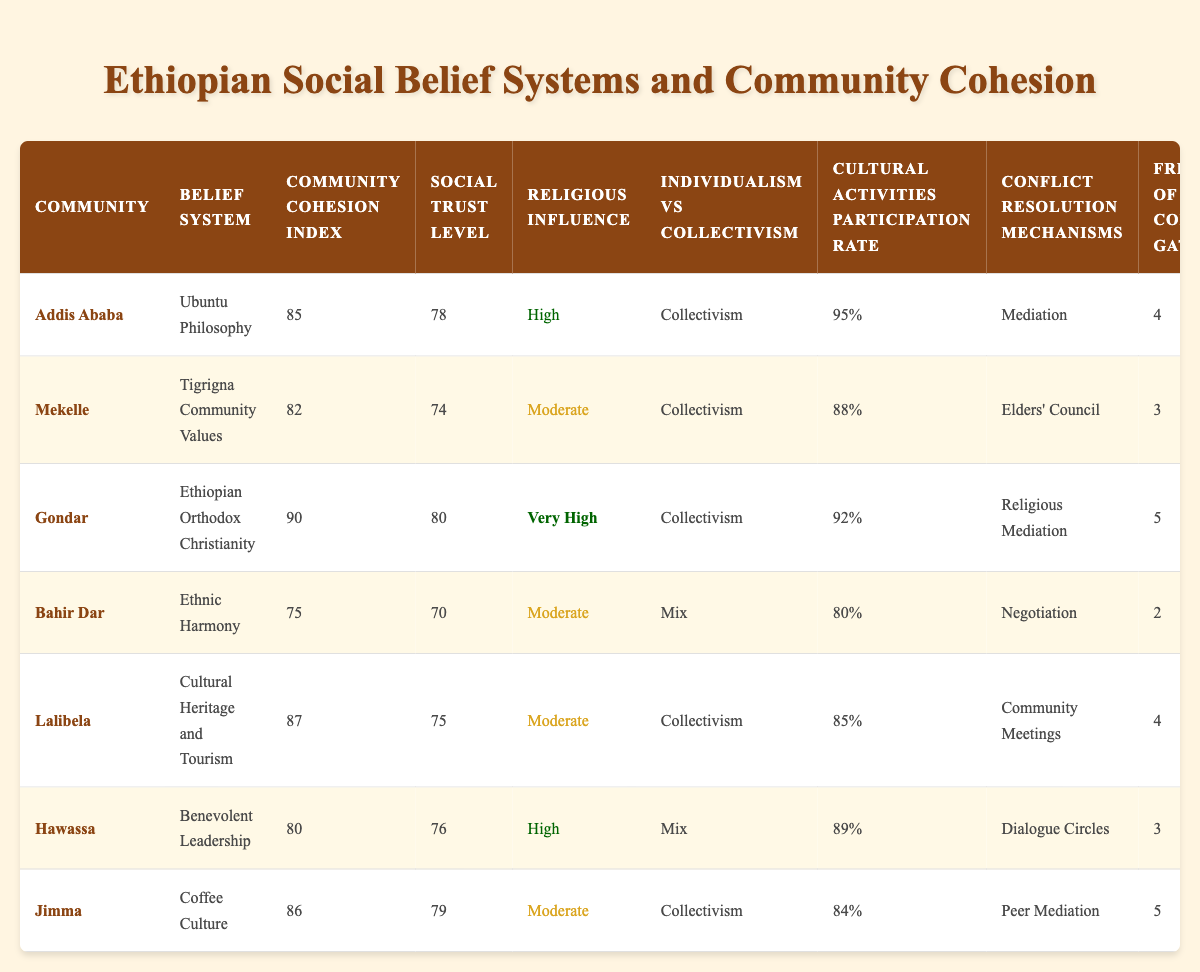What is the Community Cohesion Index for Gondar? The Community Cohesion Index is listed directly in the table under the corresponding row for Gondar, which shows a value of 90.
Answer: 90 What is the Social Trust Level for the community with the highest Community Cohesion Index? By looking at the Community Cohesion Index, Gondar has the highest value of 90. The corresponding Social Trust Level for Gondar is 80.
Answer: 80 Which community has the highest Cultural Activities Participation Rate? The Cultural Activities Participation Rate is compared across all communities, with Addis Ababa showing the highest rate at 95%.
Answer: 95% For which community is the Religious Influence rated as Very High? The table shows that the Religious Influence for Gondar is rated as Very High, as indicated in its specific row.
Answer: Gondar Which community utilizes Elders' Council for conflict resolution? By examining the Conflict Resolution Mechanisms column, it is clear that Mekelle uses Elders' Council, as stated in its corresponding row.
Answer: Mekelle What is the difference in Community Cohesion Index between Addis Ababa and Bahir Dar? The Community Cohesion Index for Addis Ababa is 85, and for Bahir Dar it is 75. The difference is calculated as 85 - 75 = 10.
Answer: 10 Is the individualism vs collectivism trend consistent across all communities? By reviewing the Individualism vs Collectivism column, it is observed that while most communities lean towards Collectivism, Bahir Dar shows a Mix, indicating that the trend is not consistent.
Answer: No Which community has the lowest perceived social support? The Perceived Social Support values are reviewed, identifying Bahir Dar with a score of 78, which is the lowest among all communities listed.
Answer: Bahir Dar Calculate the average frequency of community gatherings. To find the average, sum all the frequencies: 4 + 3 + 5 + 2 + 4 + 3 + 5 = 26. There are 7 communities, so the average is 26/7 = 3.71, rounded to 2 decimal places.
Answer: 3.71 Which communities have a high Religious Influence and a high Community Cohesion Index? The communities that match both criteria are Addis Ababa and Gondar; Addis Ababa has High Religious Influence with a Cohesion Index of 85, while Gondar has Very High Influence with a Cohesion Index of 90.
Answer: Addis Ababa, Gondar What is the total Community Cohesion Index for all communities listed? The sum of all Community Cohesion Index values is calculated as follows: 85 + 82 + 90 + 75 + 87 + 80 + 86 = 585.
Answer: 585 